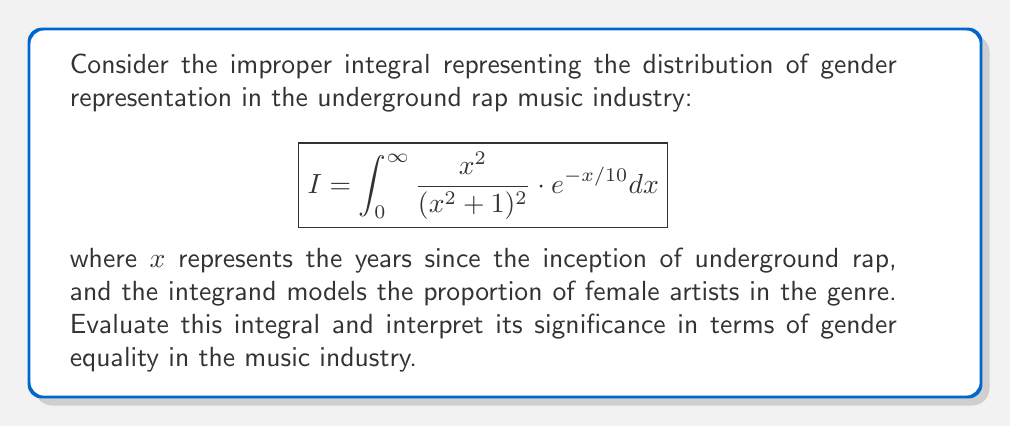Provide a solution to this math problem. To evaluate this improper integral, we'll use the following steps:

1) First, let's consider the substitution $u = x/10$. This gives us:
   $x = 10u$, $dx = 10du$, and when $x = 0$, $u = 0$; when $x \to \infty$, $u \to \infty$.

2) Applying this substitution:

   $$I = \int_0^{\infty} \frac{(10u)^2}{((10u)^2 + 1)^2} \cdot e^{-u} \cdot 10du$$

3) Simplifying:

   $$I = 1000 \int_0^{\infty} \frac{u^2}{(100u^2 + 1)^2} \cdot e^{-u} du$$

4) Now, let's use integration by parts twice. Let $v = u^2$ and $dw = e^{-u}du$.

5) After the first integration by parts:

   $$I = 1000 \left[-\frac{u^2e^{-u}}{(100u^2 + 1)^2}\right]_0^{\infty} + 1000 \int_0^{\infty} e^{-u} \cdot \frac{d}{du}\left(\frac{u^2}{(100u^2 + 1)^2}\right) du$$

6) The first term evaluates to 0. For the second term, we calculate the derivative:

   $$\frac{d}{du}\left(\frac{u^2}{(100u^2 + 1)^2}\right) = \frac{2u(100u^2 + 1)^2 - 400u^3(100u^2 + 1)}{(100u^2 + 1)^4} = \frac{2u(1 - 200u^2)}{(100u^2 + 1)^3}$$

7) Substituting this back:

   $$I = 2000 \int_0^{\infty} \frac{u(1 - 200u^2)}{(100u^2 + 1)^3} \cdot e^{-u} du$$

8) Using integration by parts again with $v = u$ and $dw = \frac{(1 - 200u^2)}{(100u^2 + 1)^3} \cdot e^{-u} du$:

   $$I = 2000 \left[-\frac{ue^{-u}(1 - 200u^2)}{(100u^2 + 1)^3}\right]_0^{\infty} + 2000 \int_0^{\infty} e^{-u} \cdot \frac{1 - 200u^2}{(100u^2 + 1)^3} du$$

9) The first term evaluates to 0. For the second term, we can use the fact that:

   $$\int_0^{\infty} \frac{e^{-u}}{(au^2 + 1)^n} du = \frac{\sqrt{\pi}}{2a^{(2n-1)/4}} \cdot \frac{\Gamma(n-1/2)}{\Gamma(n)}$$

   where $\Gamma$ is the gamma function.

10) In our case, $a = 100$, $n = 3$. Using this result:

    $$I = 2000 \cdot \frac{\sqrt{\pi}}{20\sqrt{10}} \cdot \frac{\Gamma(5/2)}{\Gamma(3)} - 400000 \cdot \frac{\sqrt{\pi}}{20\sqrt{10}} \cdot \frac{\Gamma(7/2)}{\Gamma(4)}$$

11) Simplifying and using the properties of the gamma function:

    $$I = \frac{\sqrt{\pi}}{10\sqrt{10}} \cdot \frac{3\sqrt{\pi}}{4} - \frac{\sqrt{\pi}}{10\sqrt{10}} \cdot \frac{15\sqrt{\pi}}{8} = \frac{3\pi}{40\sqrt{10}} - \frac{15\pi}{80\sqrt{10}} = \frac{3\pi}{80\sqrt{10}}$$

The result $\frac{3\pi}{80\sqrt{10}}$ represents the total area under the curve, which can be interpreted as the cumulative representation of female artists in underground rap over time. The relatively small value (approximately 0.0296) suggests that female representation in this genre has been historically low, highlighting the need for greater gender equality in the music industry.
Answer: $$I = \frac{3\pi}{80\sqrt{10}} \approx 0.0296$$ 